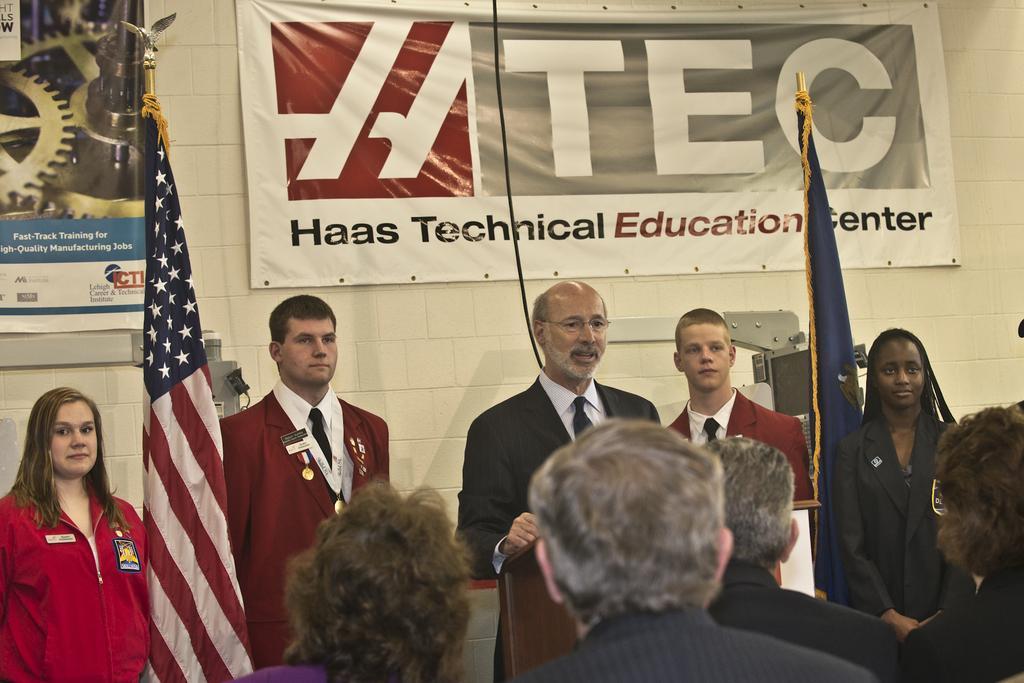How would you summarize this image in a sentence or two? Banners are on the wall. These are flags. In-front of this person there is a podium. Here we can see people. 